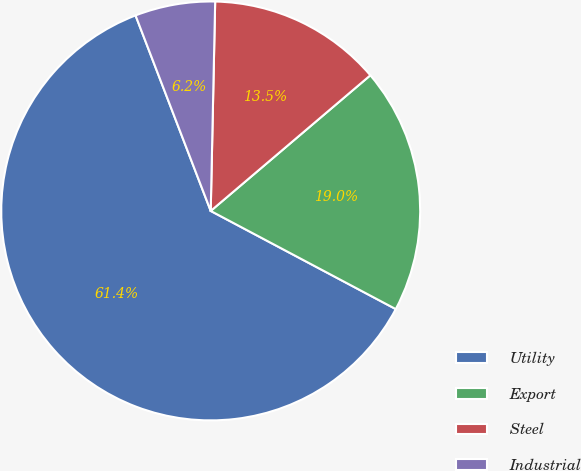Convert chart. <chart><loc_0><loc_0><loc_500><loc_500><pie_chart><fcel>Utility<fcel>Export<fcel>Steel<fcel>Industrial<nl><fcel>61.39%<fcel>18.97%<fcel>13.45%<fcel>6.18%<nl></chart> 